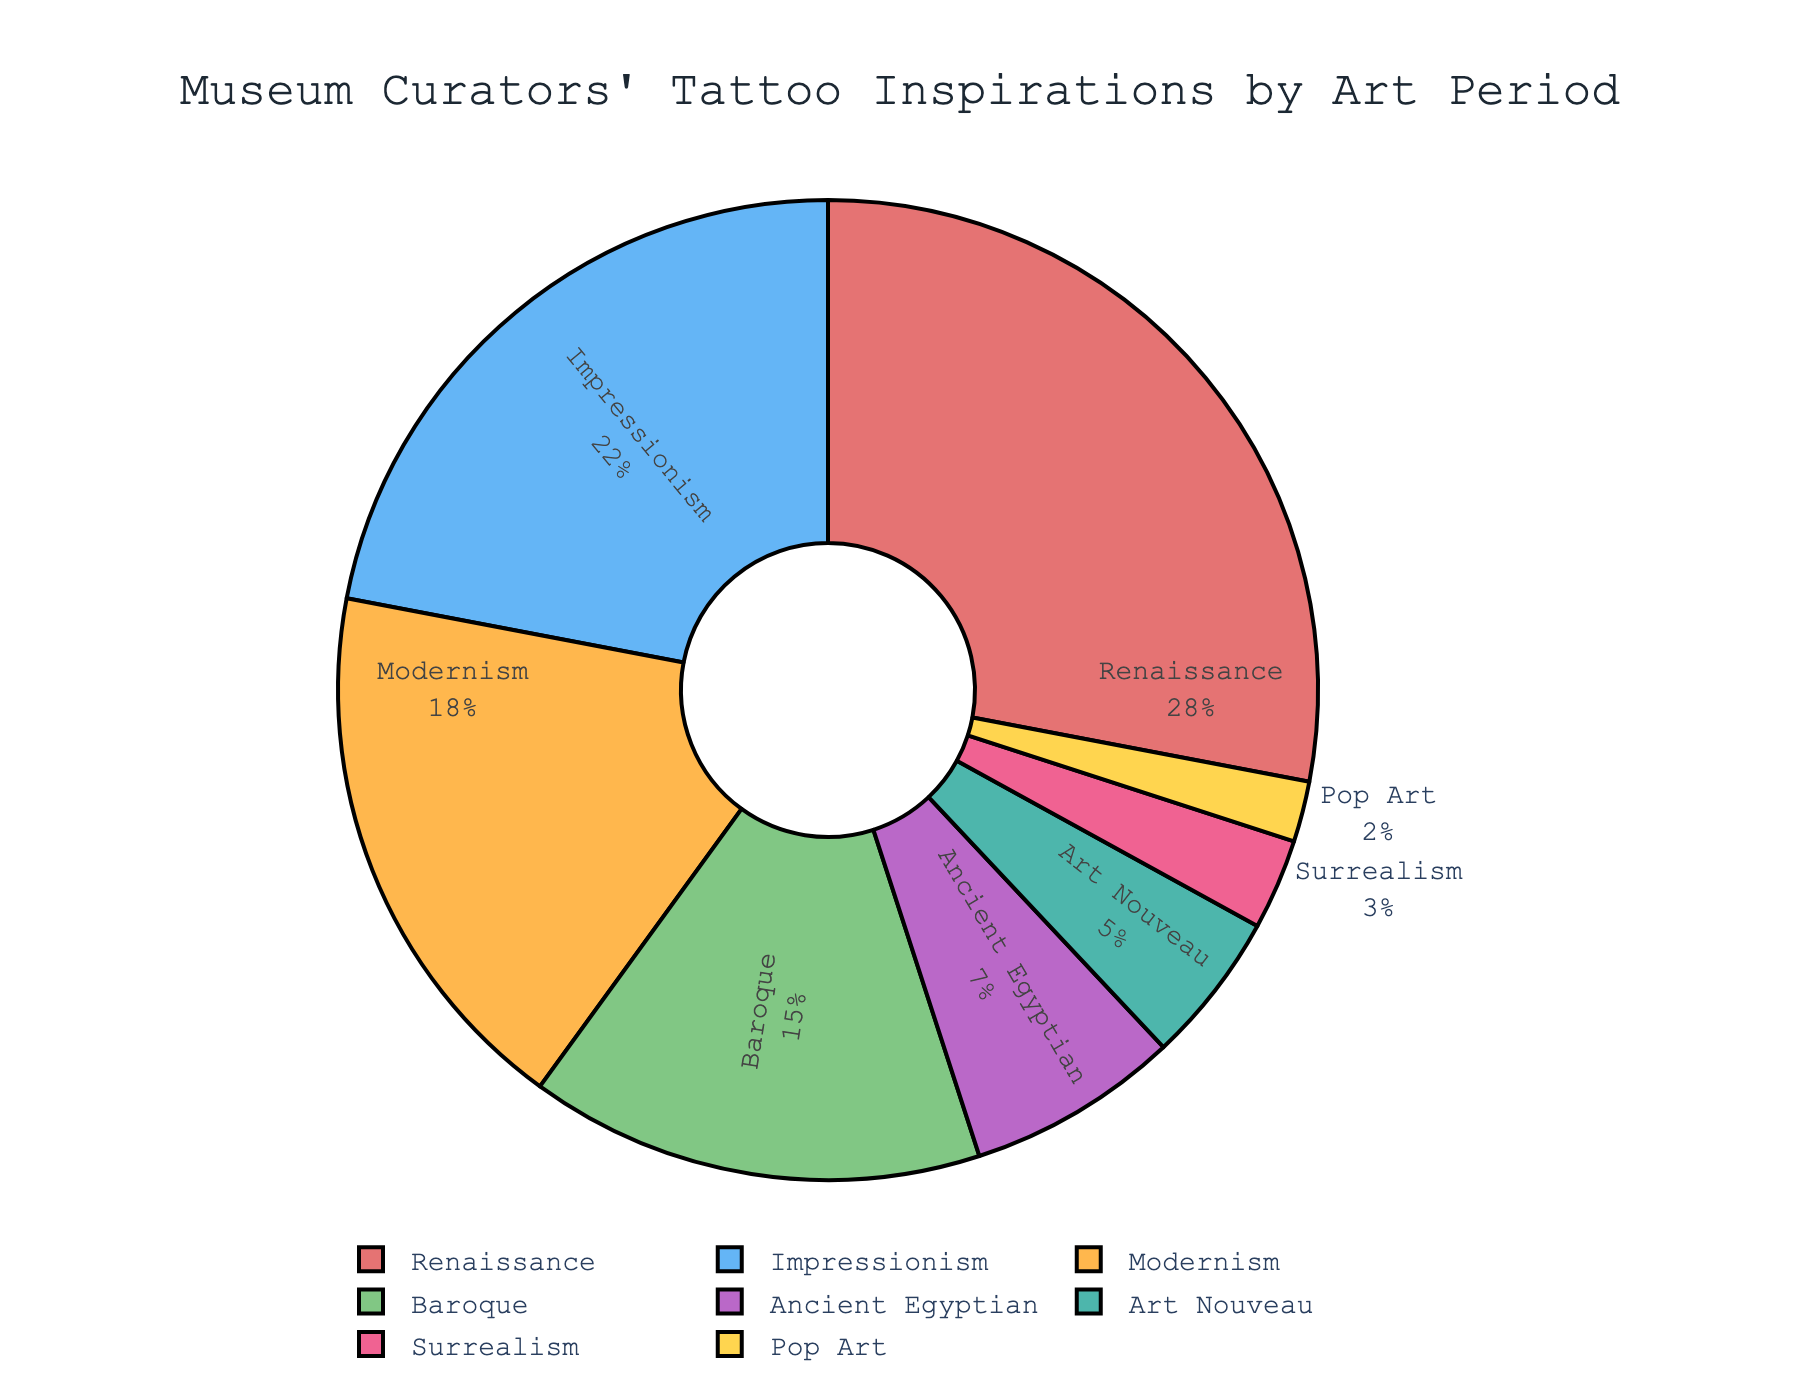What is the most popular art period for museum curator tattoos? By examining the pie chart, the segment with the largest percentage represents the most popular art period for tattoos. The Renaissance segment has the highest percentage at 28%.
Answer: Renaissance Which two art periods combined make up more than 40% of the tattoos? To find two art periods that combined sum up to more than 40%, look for combinations that exceed this threshold. Renaissance (28%) and Impressionism (22%) sum up to 50%, which is more than 40%.
Answer: Renaissance and Impressionism Which art period has the smallest proportion of tattoos? The smallest segment in the pie chart represents the art period with the least proportion. The Pop Art segment has the smallest percentage at 2%.
Answer: Pop Art How does the proportion of Modernism-inspired tattoos compare to Baroque-inspired tattoos? The segments for Modernism and Baroque can be compared by their percentages. Modernism is at 18% while Baroque is at 15%, so Modernism has a higher proportion.
Answer: Modernism is higher By how much does the proportion of Renaissance-inspired tattoos exceed the proportion of Surrealism-inspired tattoos? Subtract the percentage of Surrealism (3%) from the percentage of Renaissance (28%). 28% - 3% = 25%.
Answer: 25% What proportion of museum curators have tattoos inspired by ancient cultures (Ancient Egyptian period)? The pie chart shows the percentage of tattoos inspired by the Ancient Egyptian period, which is 7%.
Answer: 7% What is the combined percentage of the three least popular art periods for tattoos? Add the percentages of Art Nouveau (5%), Surrealism (3%), and Pop Art (2%). 5% + 3% + 2% = 10%.
Answer: 10% What visual element indicates the art period with the second smallest proportion of tattoos? By looking at the pie chart, the second smallest segment represents the second least popular art period. The Art Nouveau segment is second smallest at 5%.
Answer: Art Nouveau's segment Calculate the average percentage of tattoos inspired by Baroque, Impressionism, and Modernism periods. Sum up the percentages of Baroque (15%), Impressionism (22%), and Modernism (18%) and divide by 3. (15% + 22% + 18%) / 3 = 18.33%.
Answer: 18.33% Which art period represents roughly one-fourth (25%) of the tattoo inspirations? Identify the art period whose segment is closest to 25%. The Renaissance period, at 28%, is closest to one-fourth.
Answer: Renaissance 